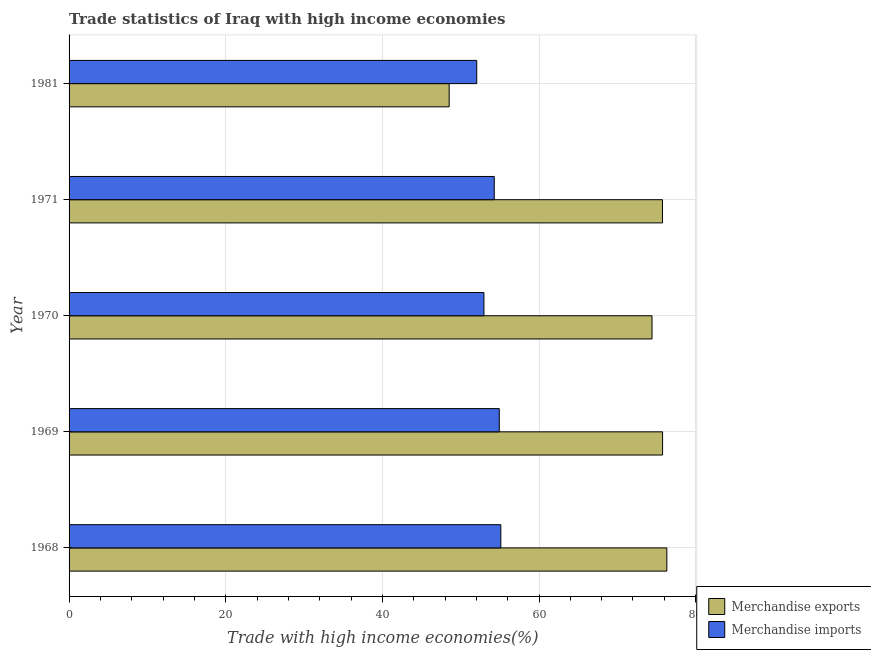How many different coloured bars are there?
Your answer should be very brief. 2. How many bars are there on the 5th tick from the top?
Offer a very short reply. 2. How many bars are there on the 3rd tick from the bottom?
Ensure brevity in your answer.  2. What is the label of the 5th group of bars from the top?
Provide a short and direct response. 1968. In how many cases, is the number of bars for a given year not equal to the number of legend labels?
Give a very brief answer. 0. What is the merchandise imports in 1969?
Make the answer very short. 54.93. Across all years, what is the maximum merchandise imports?
Make the answer very short. 55.13. Across all years, what is the minimum merchandise exports?
Your response must be concise. 48.53. In which year was the merchandise imports maximum?
Offer a terse response. 1968. What is the total merchandise imports in the graph?
Your answer should be compact. 269.36. What is the difference between the merchandise imports in 1969 and that in 1970?
Keep it short and to the point. 1.96. What is the difference between the merchandise imports in 1971 and the merchandise exports in 1970?
Offer a terse response. -20.14. What is the average merchandise exports per year?
Keep it short and to the point. 70.17. In the year 1968, what is the difference between the merchandise imports and merchandise exports?
Offer a very short reply. -21.2. In how many years, is the merchandise imports greater than 72 %?
Provide a short and direct response. 0. What is the ratio of the merchandise exports in 1968 to that in 1981?
Provide a short and direct response. 1.57. Is the merchandise exports in 1968 less than that in 1970?
Keep it short and to the point. No. What is the difference between the highest and the second highest merchandise exports?
Make the answer very short. 0.54. What is the difference between the highest and the lowest merchandise imports?
Ensure brevity in your answer.  3.08. Is the sum of the merchandise imports in 1969 and 1981 greater than the maximum merchandise exports across all years?
Make the answer very short. Yes. What does the 1st bar from the bottom in 1981 represents?
Offer a terse response. Merchandise exports. How many bars are there?
Offer a very short reply. 10. How many years are there in the graph?
Offer a terse response. 5. What is the difference between two consecutive major ticks on the X-axis?
Keep it short and to the point. 20. Does the graph contain grids?
Provide a succinct answer. Yes. How are the legend labels stacked?
Offer a terse response. Vertical. What is the title of the graph?
Keep it short and to the point. Trade statistics of Iraq with high income economies. What is the label or title of the X-axis?
Offer a terse response. Trade with high income economies(%). What is the Trade with high income economies(%) in Merchandise exports in 1968?
Your answer should be compact. 76.32. What is the Trade with high income economies(%) of Merchandise imports in 1968?
Offer a very short reply. 55.13. What is the Trade with high income economies(%) of Merchandise exports in 1969?
Make the answer very short. 75.78. What is the Trade with high income economies(%) in Merchandise imports in 1969?
Your answer should be very brief. 54.93. What is the Trade with high income economies(%) of Merchandise exports in 1970?
Give a very brief answer. 74.43. What is the Trade with high income economies(%) of Merchandise imports in 1970?
Provide a succinct answer. 52.97. What is the Trade with high income economies(%) in Merchandise exports in 1971?
Keep it short and to the point. 75.77. What is the Trade with high income economies(%) of Merchandise imports in 1971?
Ensure brevity in your answer.  54.29. What is the Trade with high income economies(%) of Merchandise exports in 1981?
Your answer should be compact. 48.53. What is the Trade with high income economies(%) in Merchandise imports in 1981?
Offer a very short reply. 52.05. Across all years, what is the maximum Trade with high income economies(%) in Merchandise exports?
Ensure brevity in your answer.  76.32. Across all years, what is the maximum Trade with high income economies(%) of Merchandise imports?
Provide a short and direct response. 55.13. Across all years, what is the minimum Trade with high income economies(%) of Merchandise exports?
Offer a very short reply. 48.53. Across all years, what is the minimum Trade with high income economies(%) of Merchandise imports?
Offer a very short reply. 52.05. What is the total Trade with high income economies(%) in Merchandise exports in the graph?
Make the answer very short. 350.83. What is the total Trade with high income economies(%) in Merchandise imports in the graph?
Your answer should be compact. 269.36. What is the difference between the Trade with high income economies(%) of Merchandise exports in 1968 and that in 1969?
Ensure brevity in your answer.  0.54. What is the difference between the Trade with high income economies(%) of Merchandise imports in 1968 and that in 1969?
Your response must be concise. 0.2. What is the difference between the Trade with high income economies(%) in Merchandise exports in 1968 and that in 1970?
Your response must be concise. 1.89. What is the difference between the Trade with high income economies(%) of Merchandise imports in 1968 and that in 1970?
Your answer should be very brief. 2.16. What is the difference between the Trade with high income economies(%) of Merchandise exports in 1968 and that in 1971?
Provide a succinct answer. 0.56. What is the difference between the Trade with high income economies(%) in Merchandise imports in 1968 and that in 1971?
Your answer should be compact. 0.84. What is the difference between the Trade with high income economies(%) of Merchandise exports in 1968 and that in 1981?
Provide a succinct answer. 27.79. What is the difference between the Trade with high income economies(%) in Merchandise imports in 1968 and that in 1981?
Provide a short and direct response. 3.08. What is the difference between the Trade with high income economies(%) of Merchandise exports in 1969 and that in 1970?
Keep it short and to the point. 1.35. What is the difference between the Trade with high income economies(%) in Merchandise imports in 1969 and that in 1970?
Your answer should be very brief. 1.96. What is the difference between the Trade with high income economies(%) of Merchandise exports in 1969 and that in 1971?
Ensure brevity in your answer.  0.01. What is the difference between the Trade with high income economies(%) of Merchandise imports in 1969 and that in 1971?
Provide a short and direct response. 0.64. What is the difference between the Trade with high income economies(%) in Merchandise exports in 1969 and that in 1981?
Make the answer very short. 27.25. What is the difference between the Trade with high income economies(%) of Merchandise imports in 1969 and that in 1981?
Offer a very short reply. 2.88. What is the difference between the Trade with high income economies(%) in Merchandise exports in 1970 and that in 1971?
Make the answer very short. -1.34. What is the difference between the Trade with high income economies(%) of Merchandise imports in 1970 and that in 1971?
Provide a succinct answer. -1.32. What is the difference between the Trade with high income economies(%) in Merchandise exports in 1970 and that in 1981?
Keep it short and to the point. 25.9. What is the difference between the Trade with high income economies(%) of Merchandise imports in 1970 and that in 1981?
Your response must be concise. 0.92. What is the difference between the Trade with high income economies(%) in Merchandise exports in 1971 and that in 1981?
Give a very brief answer. 27.23. What is the difference between the Trade with high income economies(%) in Merchandise imports in 1971 and that in 1981?
Your answer should be compact. 2.24. What is the difference between the Trade with high income economies(%) of Merchandise exports in 1968 and the Trade with high income economies(%) of Merchandise imports in 1969?
Provide a succinct answer. 21.39. What is the difference between the Trade with high income economies(%) in Merchandise exports in 1968 and the Trade with high income economies(%) in Merchandise imports in 1970?
Your answer should be compact. 23.35. What is the difference between the Trade with high income economies(%) in Merchandise exports in 1968 and the Trade with high income economies(%) in Merchandise imports in 1971?
Your answer should be compact. 22.04. What is the difference between the Trade with high income economies(%) of Merchandise exports in 1968 and the Trade with high income economies(%) of Merchandise imports in 1981?
Offer a terse response. 24.27. What is the difference between the Trade with high income economies(%) in Merchandise exports in 1969 and the Trade with high income economies(%) in Merchandise imports in 1970?
Make the answer very short. 22.81. What is the difference between the Trade with high income economies(%) of Merchandise exports in 1969 and the Trade with high income economies(%) of Merchandise imports in 1971?
Keep it short and to the point. 21.49. What is the difference between the Trade with high income economies(%) of Merchandise exports in 1969 and the Trade with high income economies(%) of Merchandise imports in 1981?
Your answer should be compact. 23.73. What is the difference between the Trade with high income economies(%) in Merchandise exports in 1970 and the Trade with high income economies(%) in Merchandise imports in 1971?
Your answer should be compact. 20.14. What is the difference between the Trade with high income economies(%) of Merchandise exports in 1970 and the Trade with high income economies(%) of Merchandise imports in 1981?
Keep it short and to the point. 22.38. What is the difference between the Trade with high income economies(%) of Merchandise exports in 1971 and the Trade with high income economies(%) of Merchandise imports in 1981?
Your response must be concise. 23.72. What is the average Trade with high income economies(%) of Merchandise exports per year?
Your answer should be compact. 70.17. What is the average Trade with high income economies(%) of Merchandise imports per year?
Your answer should be very brief. 53.87. In the year 1968, what is the difference between the Trade with high income economies(%) in Merchandise exports and Trade with high income economies(%) in Merchandise imports?
Make the answer very short. 21.2. In the year 1969, what is the difference between the Trade with high income economies(%) of Merchandise exports and Trade with high income economies(%) of Merchandise imports?
Keep it short and to the point. 20.85. In the year 1970, what is the difference between the Trade with high income economies(%) of Merchandise exports and Trade with high income economies(%) of Merchandise imports?
Offer a very short reply. 21.46. In the year 1971, what is the difference between the Trade with high income economies(%) in Merchandise exports and Trade with high income economies(%) in Merchandise imports?
Provide a short and direct response. 21.48. In the year 1981, what is the difference between the Trade with high income economies(%) in Merchandise exports and Trade with high income economies(%) in Merchandise imports?
Provide a short and direct response. -3.52. What is the ratio of the Trade with high income economies(%) in Merchandise imports in 1968 to that in 1969?
Make the answer very short. 1. What is the ratio of the Trade with high income economies(%) in Merchandise exports in 1968 to that in 1970?
Make the answer very short. 1.03. What is the ratio of the Trade with high income economies(%) of Merchandise imports in 1968 to that in 1970?
Your answer should be compact. 1.04. What is the ratio of the Trade with high income economies(%) of Merchandise exports in 1968 to that in 1971?
Offer a very short reply. 1.01. What is the ratio of the Trade with high income economies(%) of Merchandise imports in 1968 to that in 1971?
Offer a very short reply. 1.02. What is the ratio of the Trade with high income economies(%) of Merchandise exports in 1968 to that in 1981?
Ensure brevity in your answer.  1.57. What is the ratio of the Trade with high income economies(%) in Merchandise imports in 1968 to that in 1981?
Offer a very short reply. 1.06. What is the ratio of the Trade with high income economies(%) of Merchandise exports in 1969 to that in 1970?
Provide a short and direct response. 1.02. What is the ratio of the Trade with high income economies(%) of Merchandise imports in 1969 to that in 1971?
Ensure brevity in your answer.  1.01. What is the ratio of the Trade with high income economies(%) in Merchandise exports in 1969 to that in 1981?
Provide a short and direct response. 1.56. What is the ratio of the Trade with high income economies(%) of Merchandise imports in 1969 to that in 1981?
Your answer should be compact. 1.06. What is the ratio of the Trade with high income economies(%) in Merchandise exports in 1970 to that in 1971?
Provide a short and direct response. 0.98. What is the ratio of the Trade with high income economies(%) in Merchandise imports in 1970 to that in 1971?
Provide a short and direct response. 0.98. What is the ratio of the Trade with high income economies(%) of Merchandise exports in 1970 to that in 1981?
Ensure brevity in your answer.  1.53. What is the ratio of the Trade with high income economies(%) of Merchandise imports in 1970 to that in 1981?
Offer a terse response. 1.02. What is the ratio of the Trade with high income economies(%) of Merchandise exports in 1971 to that in 1981?
Give a very brief answer. 1.56. What is the ratio of the Trade with high income economies(%) in Merchandise imports in 1971 to that in 1981?
Offer a terse response. 1.04. What is the difference between the highest and the second highest Trade with high income economies(%) of Merchandise exports?
Offer a terse response. 0.54. What is the difference between the highest and the second highest Trade with high income economies(%) in Merchandise imports?
Your answer should be very brief. 0.2. What is the difference between the highest and the lowest Trade with high income economies(%) in Merchandise exports?
Make the answer very short. 27.79. What is the difference between the highest and the lowest Trade with high income economies(%) in Merchandise imports?
Provide a short and direct response. 3.08. 